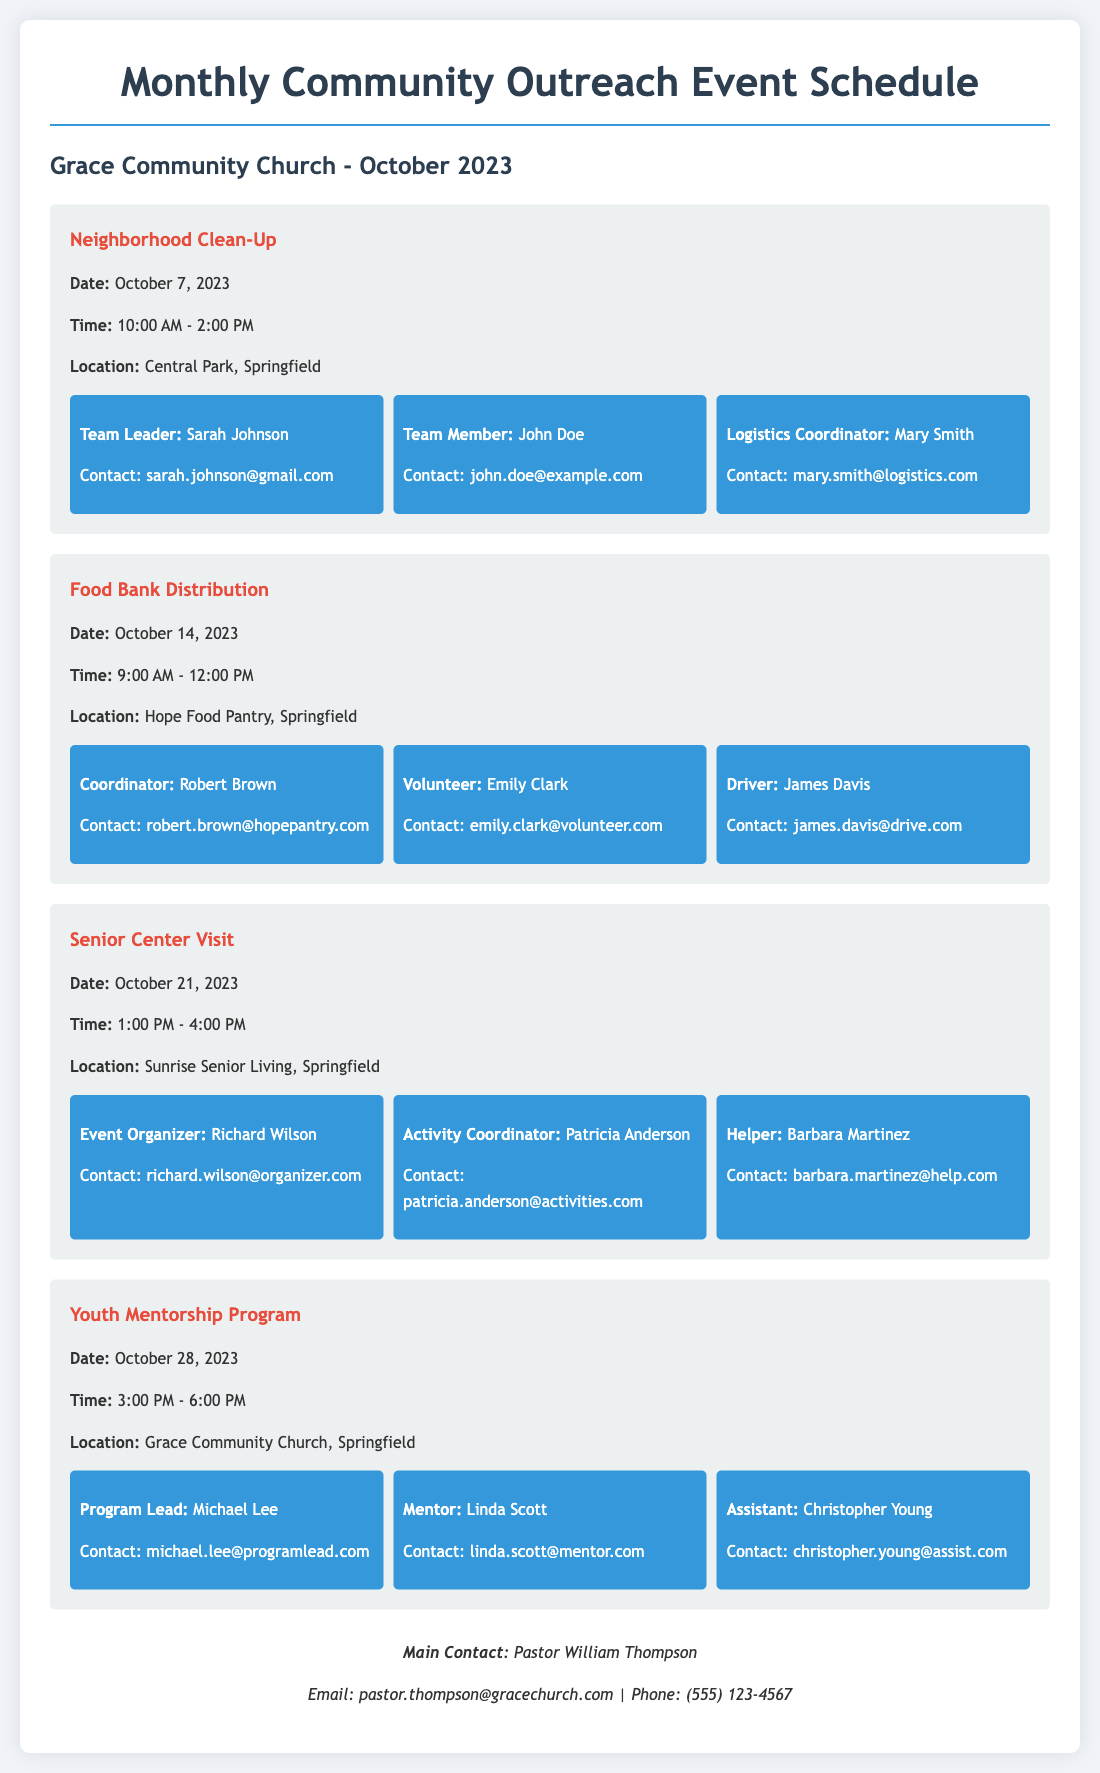What is the date of the Neighborhood Clean-Up event? The date for the Neighborhood Clean-Up event is specified in the document as October 7, 2023.
Answer: October 7, 2023 Who is the Team Leader for the Neighborhood Clean-Up? The Team Leader for the Neighborhood Clean-Up is mentioned as Sarah Johnson.
Answer: Sarah Johnson What time does the Food Bank Distribution event start? The start time for the Food Bank Distribution event is indicated as 9:00 AM.
Answer: 9:00 AM Which location will host the Youth Mentorship Program? The document states that the Youth Mentorship Program will occur at Grace Community Church, Springfield.
Answer: Grace Community Church, Springfield How many volunteer roles are mentioned for the Senior Center Visit? The document lists three volunteer roles for the Senior Center Visit, indicating that there are three specific volunteers.
Answer: 3 What is the email contact for Pastor William Thompson? The email contact for Pastor William Thompson is provided as pastor.thompson@gracechurch.com.
Answer: pastor.thompson@gracechurch.com Who is the Coordinator for the Food Bank Distribution? Robert Brown is identified as the Coordinator for the Food Bank Distribution event.
Answer: Robert Brown What is the time range for the Senior Center Visit? The time range for the Senior Center Visit is specified from 1:00 PM to 4:00 PM.
Answer: 1:00 PM - 4:00 PM 